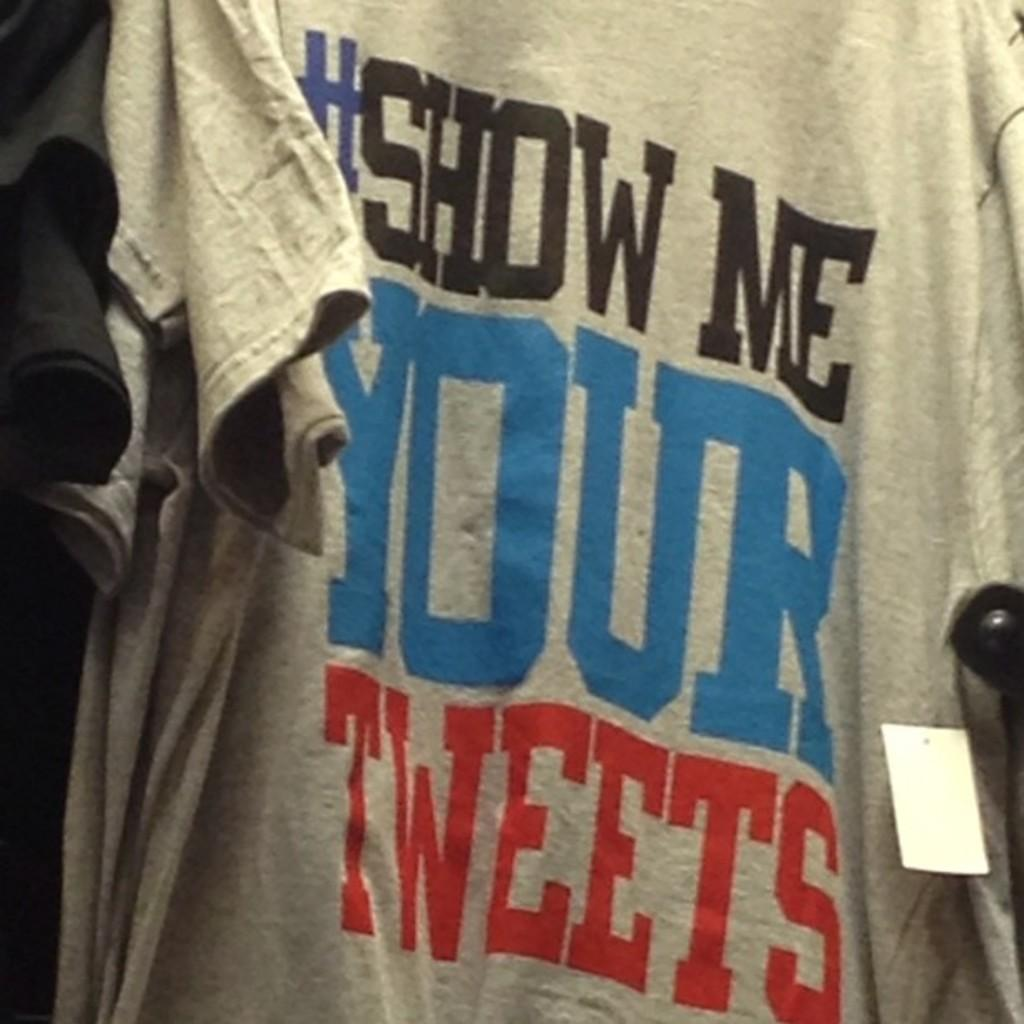<image>
Provide a brief description of the given image. the word your that is on a gray shirt 